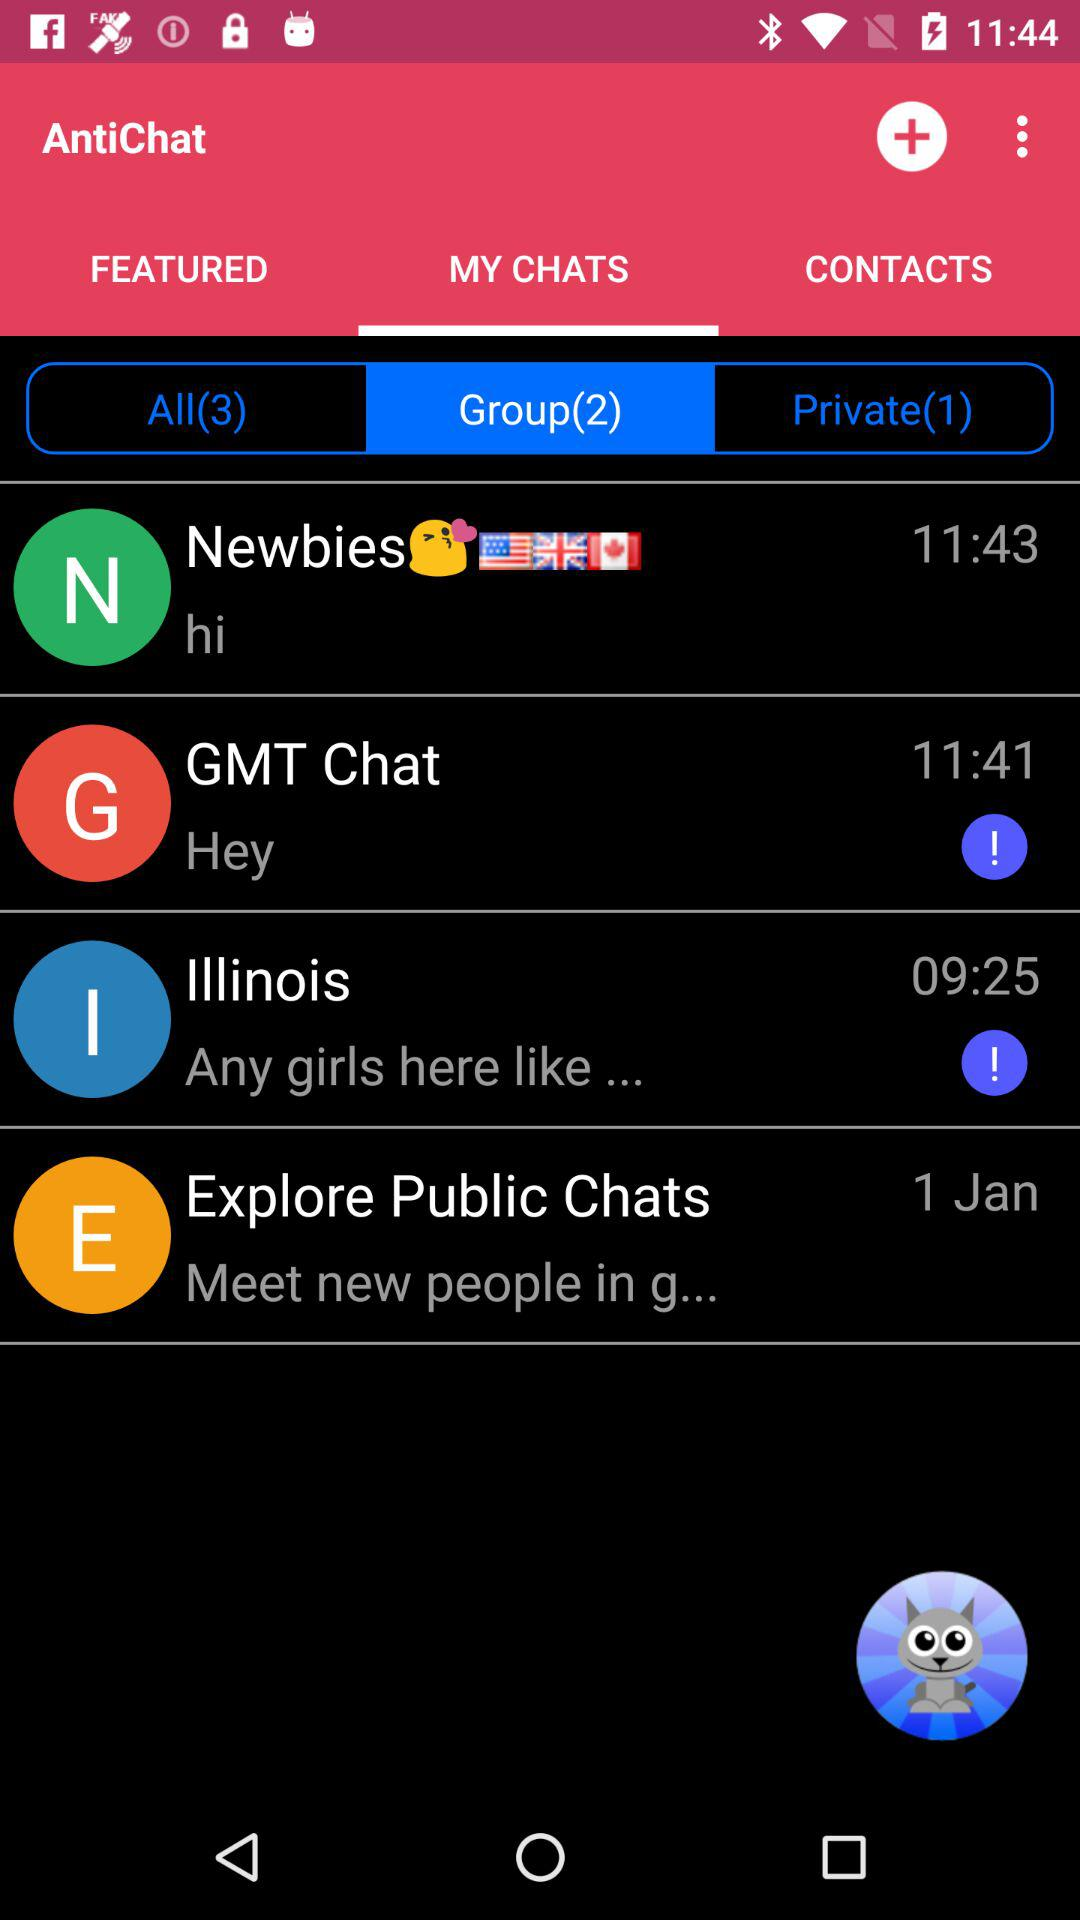How many private chats are there?
Answer the question using a single word or phrase. 1 